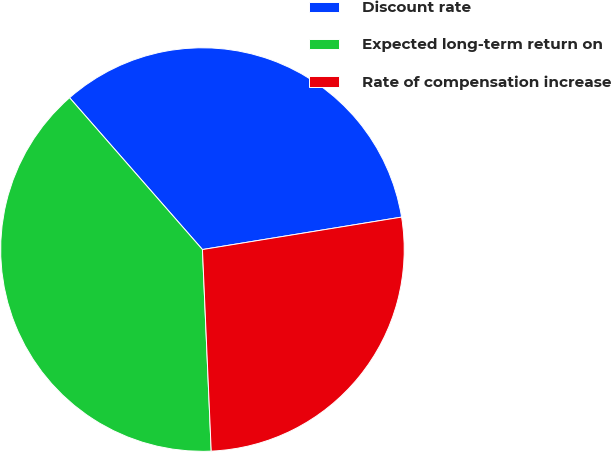<chart> <loc_0><loc_0><loc_500><loc_500><pie_chart><fcel>Discount rate<fcel>Expected long-term return on<fcel>Rate of compensation increase<nl><fcel>33.87%<fcel>39.25%<fcel>26.88%<nl></chart> 